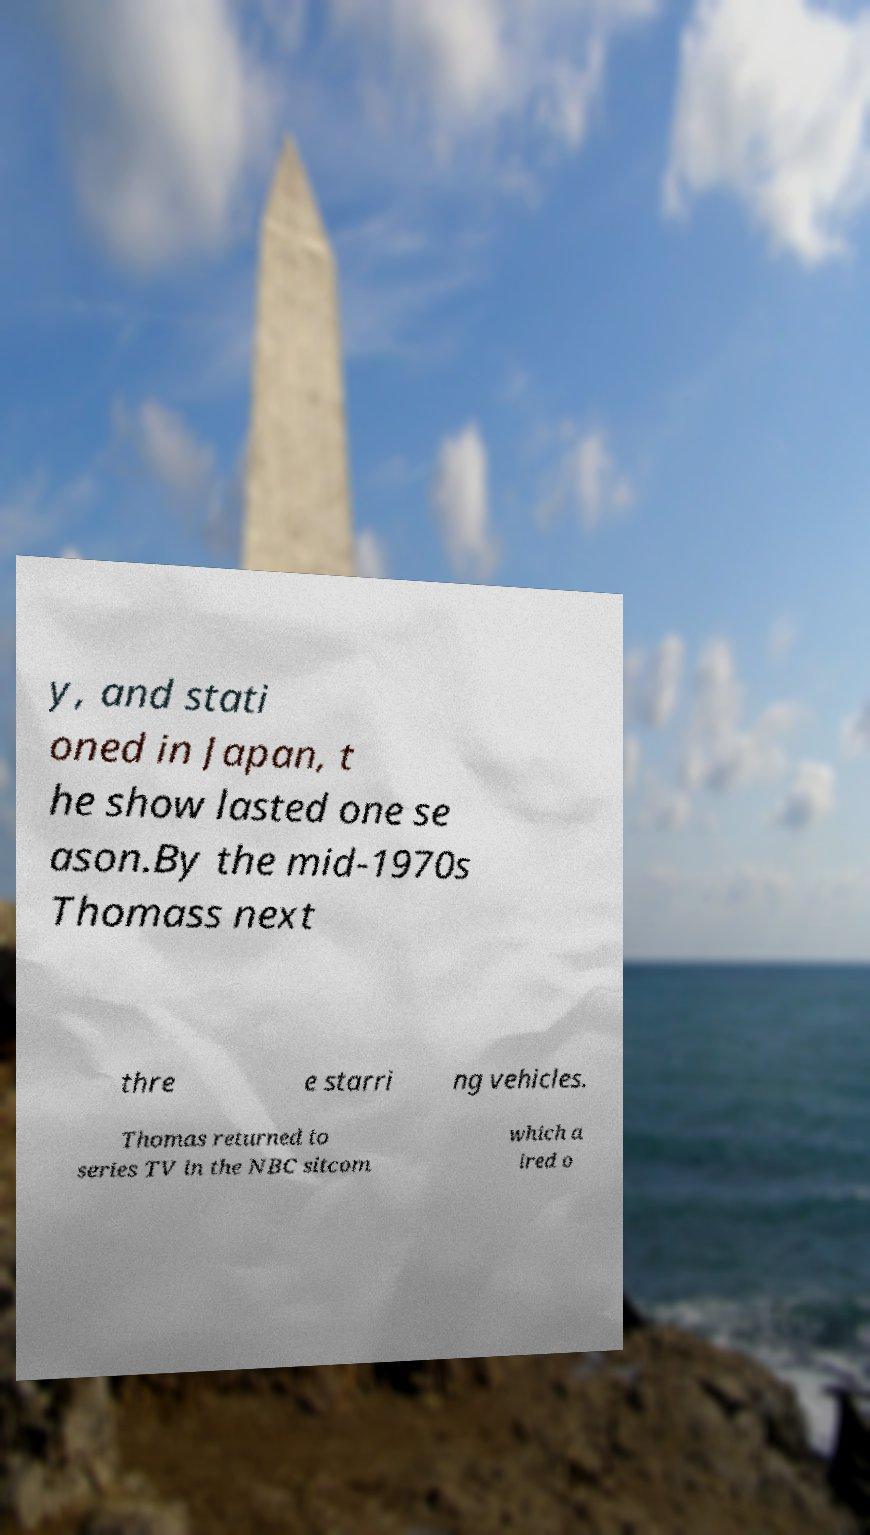I need the written content from this picture converted into text. Can you do that? y, and stati oned in Japan, t he show lasted one se ason.By the mid-1970s Thomass next thre e starri ng vehicles. Thomas returned to series TV in the NBC sitcom which a ired o 